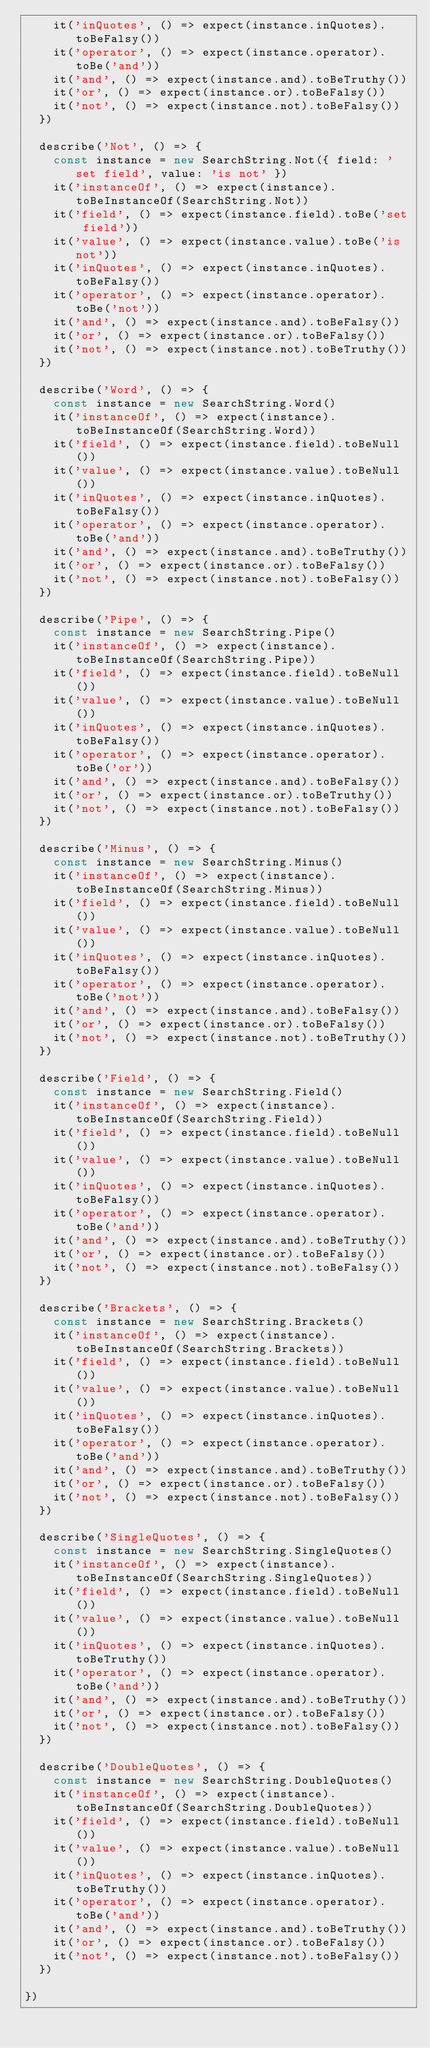Convert code to text. <code><loc_0><loc_0><loc_500><loc_500><_JavaScript_>    it('inQuotes', () => expect(instance.inQuotes).toBeFalsy())
    it('operator', () => expect(instance.operator).toBe('and'))
    it('and', () => expect(instance.and).toBeTruthy())
    it('or', () => expect(instance.or).toBeFalsy())
    it('not', () => expect(instance.not).toBeFalsy())
  })

  describe('Not', () => {
    const instance = new SearchString.Not({ field: 'set field', value: 'is not' })
    it('instanceOf', () => expect(instance).toBeInstanceOf(SearchString.Not))
    it('field', () => expect(instance.field).toBe('set field'))
    it('value', () => expect(instance.value).toBe('is not'))
    it('inQuotes', () => expect(instance.inQuotes).toBeFalsy())
    it('operator', () => expect(instance.operator).toBe('not'))
    it('and', () => expect(instance.and).toBeFalsy())
    it('or', () => expect(instance.or).toBeFalsy())
    it('not', () => expect(instance.not).toBeTruthy())
  })

  describe('Word', () => {
    const instance = new SearchString.Word()
    it('instanceOf', () => expect(instance).toBeInstanceOf(SearchString.Word))
    it('field', () => expect(instance.field).toBeNull())
    it('value', () => expect(instance.value).toBeNull())
    it('inQuotes', () => expect(instance.inQuotes).toBeFalsy())
    it('operator', () => expect(instance.operator).toBe('and'))
    it('and', () => expect(instance.and).toBeTruthy())
    it('or', () => expect(instance.or).toBeFalsy())
    it('not', () => expect(instance.not).toBeFalsy())
  })

  describe('Pipe', () => {
    const instance = new SearchString.Pipe()
    it('instanceOf', () => expect(instance).toBeInstanceOf(SearchString.Pipe))
    it('field', () => expect(instance.field).toBeNull())
    it('value', () => expect(instance.value).toBeNull())
    it('inQuotes', () => expect(instance.inQuotes).toBeFalsy())
    it('operator', () => expect(instance.operator).toBe('or'))
    it('and', () => expect(instance.and).toBeFalsy())
    it('or', () => expect(instance.or).toBeTruthy())
    it('not', () => expect(instance.not).toBeFalsy())
  })

  describe('Minus', () => {
    const instance = new SearchString.Minus()
    it('instanceOf', () => expect(instance).toBeInstanceOf(SearchString.Minus))
    it('field', () => expect(instance.field).toBeNull())
    it('value', () => expect(instance.value).toBeNull())
    it('inQuotes', () => expect(instance.inQuotes).toBeFalsy())
    it('operator', () => expect(instance.operator).toBe('not'))
    it('and', () => expect(instance.and).toBeFalsy())
    it('or', () => expect(instance.or).toBeFalsy())
    it('not', () => expect(instance.not).toBeTruthy())
  })

  describe('Field', () => {
    const instance = new SearchString.Field()
    it('instanceOf', () => expect(instance).toBeInstanceOf(SearchString.Field))
    it('field', () => expect(instance.field).toBeNull())
    it('value', () => expect(instance.value).toBeNull())
    it('inQuotes', () => expect(instance.inQuotes).toBeFalsy())
    it('operator', () => expect(instance.operator).toBe('and'))
    it('and', () => expect(instance.and).toBeTruthy())
    it('or', () => expect(instance.or).toBeFalsy())
    it('not', () => expect(instance.not).toBeFalsy())
  })

  describe('Brackets', () => {
    const instance = new SearchString.Brackets()
    it('instanceOf', () => expect(instance).toBeInstanceOf(SearchString.Brackets))
    it('field', () => expect(instance.field).toBeNull())
    it('value', () => expect(instance.value).toBeNull())
    it('inQuotes', () => expect(instance.inQuotes).toBeFalsy())
    it('operator', () => expect(instance.operator).toBe('and'))
    it('and', () => expect(instance.and).toBeTruthy())
    it('or', () => expect(instance.or).toBeFalsy())
    it('not', () => expect(instance.not).toBeFalsy())
  })

  describe('SingleQuotes', () => {
    const instance = new SearchString.SingleQuotes()
    it('instanceOf', () => expect(instance).toBeInstanceOf(SearchString.SingleQuotes))
    it('field', () => expect(instance.field).toBeNull())
    it('value', () => expect(instance.value).toBeNull())
    it('inQuotes', () => expect(instance.inQuotes).toBeTruthy())
    it('operator', () => expect(instance.operator).toBe('and'))
    it('and', () => expect(instance.and).toBeTruthy())
    it('or', () => expect(instance.or).toBeFalsy())
    it('not', () => expect(instance.not).toBeFalsy())
  })
  
  describe('DoubleQuotes', () => {
    const instance = new SearchString.DoubleQuotes()
    it('instanceOf', () => expect(instance).toBeInstanceOf(SearchString.DoubleQuotes))
    it('field', () => expect(instance.field).toBeNull())
    it('value', () => expect(instance.value).toBeNull())
    it('inQuotes', () => expect(instance.inQuotes).toBeTruthy())
    it('operator', () => expect(instance.operator).toBe('and'))
    it('and', () => expect(instance.and).toBeTruthy())
    it('or', () => expect(instance.or).toBeFalsy())
    it('not', () => expect(instance.not).toBeFalsy())
  })

})
</code> 